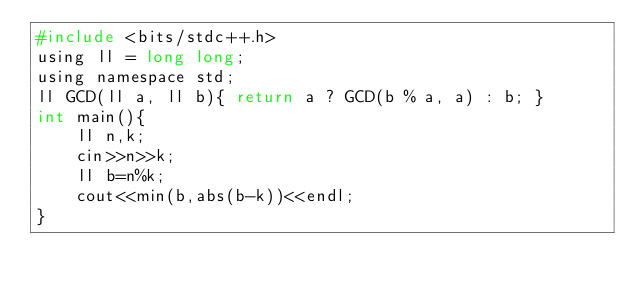Convert code to text. <code><loc_0><loc_0><loc_500><loc_500><_C_>#include <bits/stdc++.h>
using ll = long long;
using namespace std;
ll GCD(ll a, ll b){ return a ? GCD(b % a, a) : b; }
int main(){
    ll n,k;
    cin>>n>>k;
    ll b=n%k;
    cout<<min(b,abs(b-k))<<endl;
}</code> 